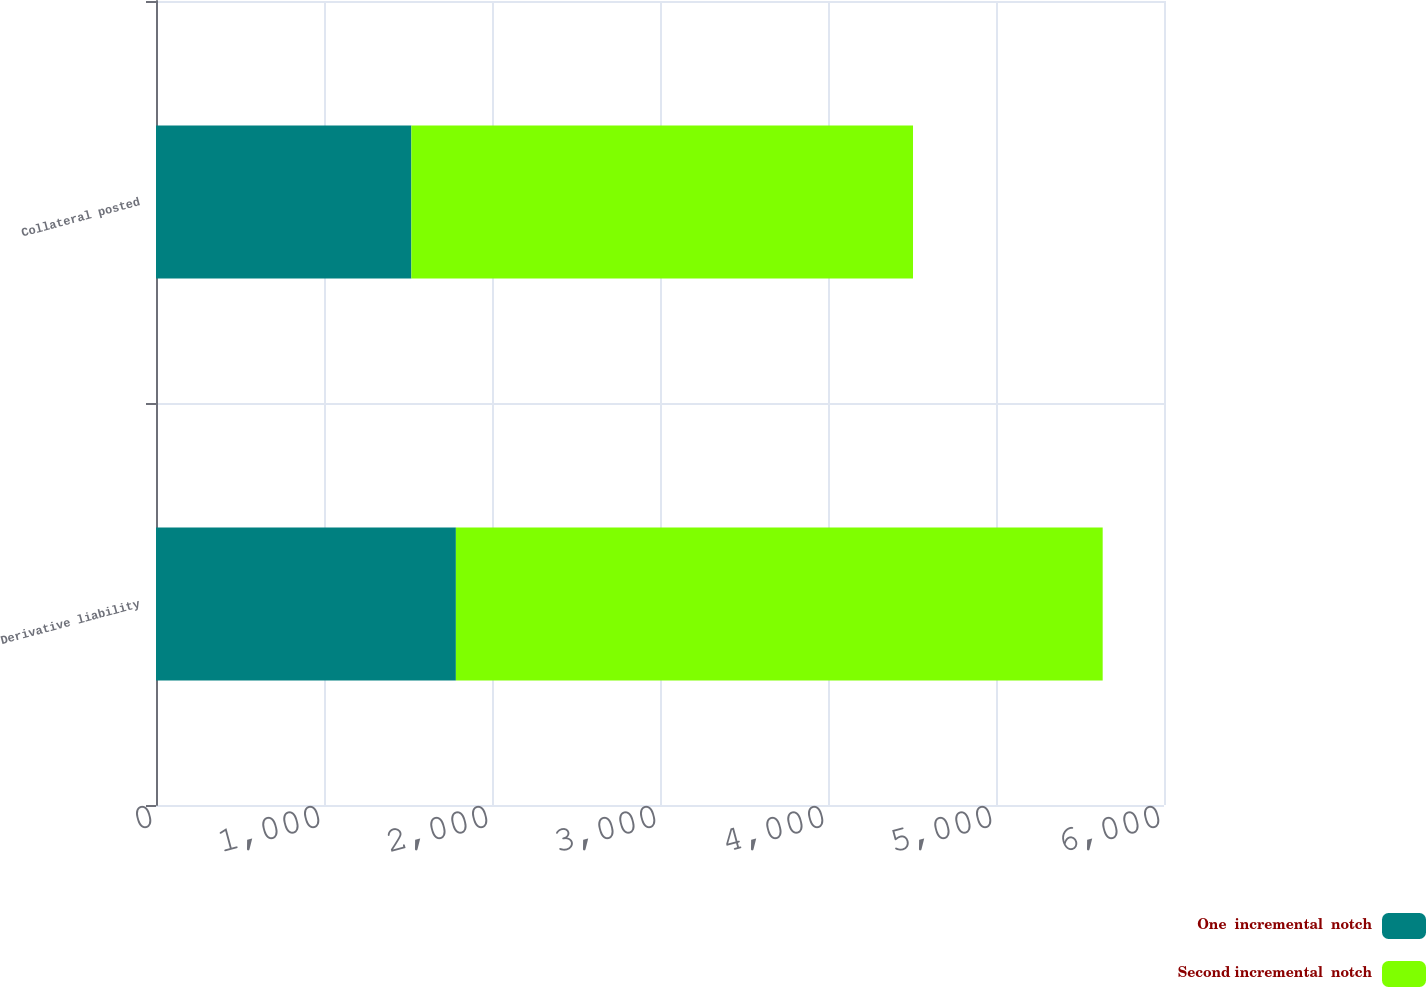Convert chart to OTSL. <chart><loc_0><loc_0><loc_500><loc_500><stacked_bar_chart><ecel><fcel>Derivative liability<fcel>Collateral posted<nl><fcel>One  incremental  notch<fcel>1785<fcel>1520<nl><fcel>Second incremental  notch<fcel>3850<fcel>2986<nl></chart> 